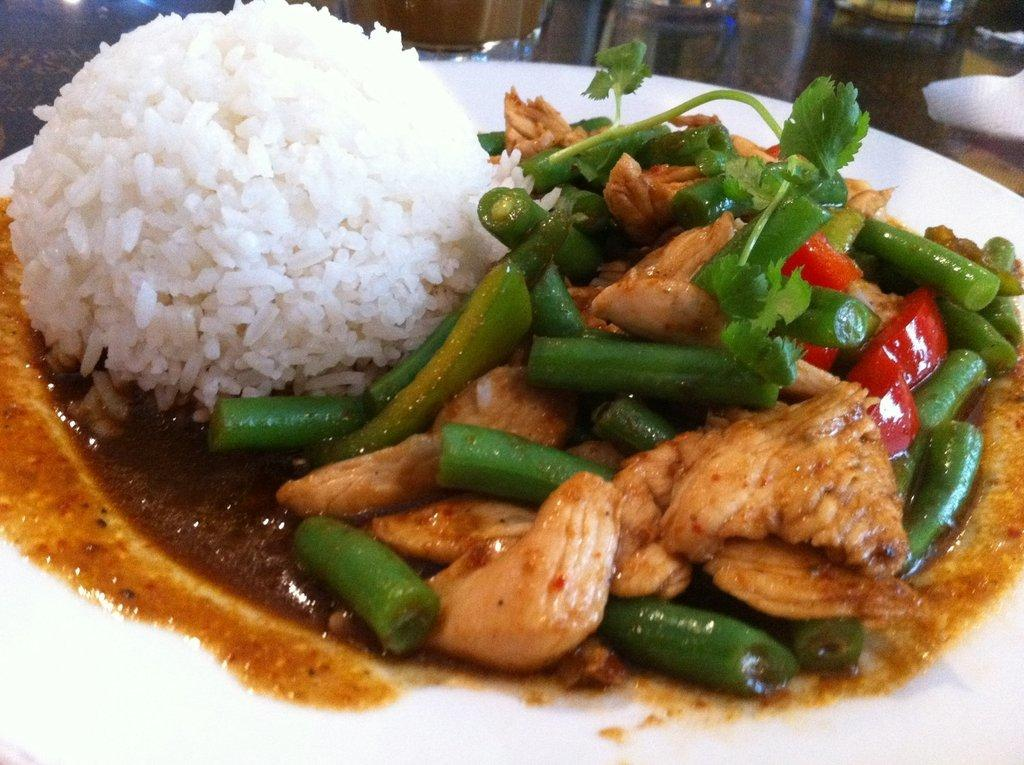What is located in the foreground of the image? There is a plate in the foreground of the image. What is on the plate? The plate contains rice and some food. What can be seen in the background of the image? There is a tissue paper and other objects visible in the background of the image. What type of yak can be seen in the image? There is no yak present in the image. How many eggs are visible on the plate? The image does not show any eggs on the plate; it contains rice and some food. 